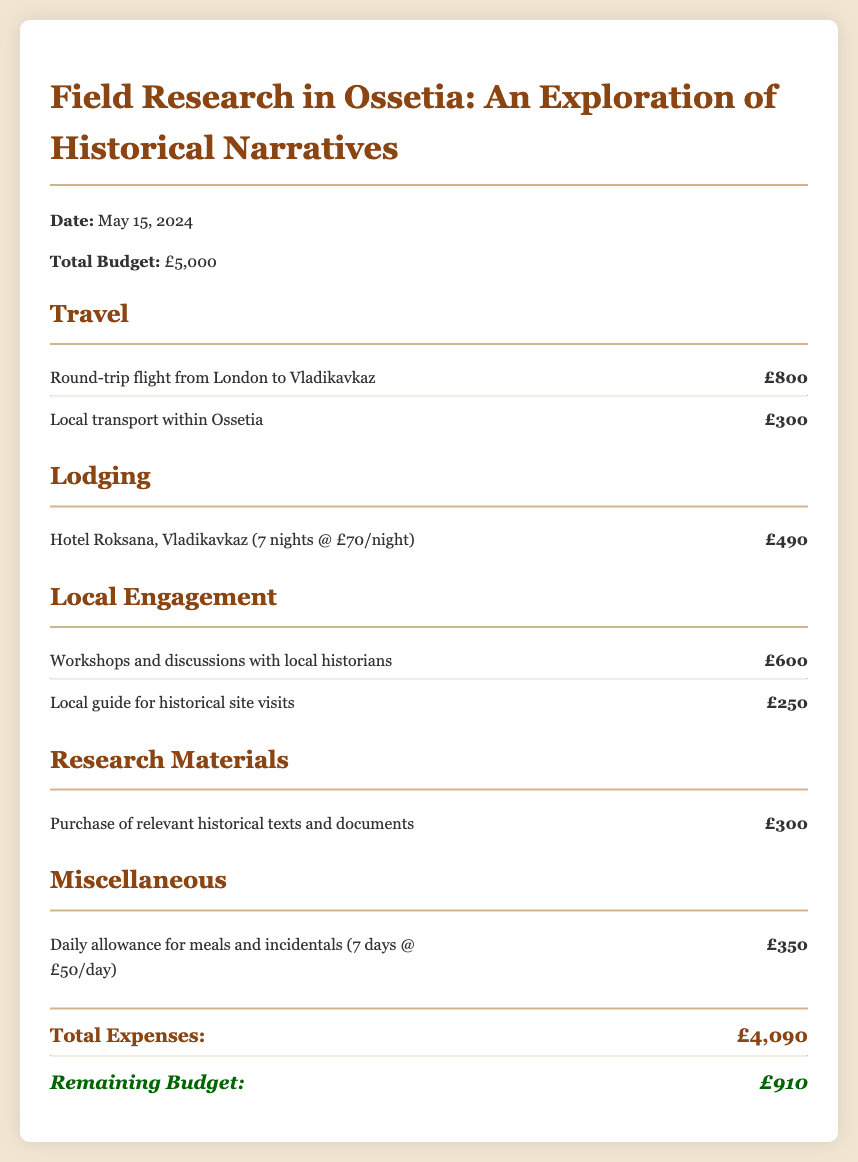what is the date of the research project? The date of the research project is stated at the beginning of the document.
Answer: May 15, 2024 what is the total budget for the research? The total budget is mentioned in the budget overview at the top of the document.
Answer: £5,000 how much is allocated for local transport within Ossetia? The amount for local transport is detailed in the travel section of the budget.
Answer: £300 what is the cost of lodging at Hotel Roksana for 7 nights? The cost of lodging is calculated based on the nightly rate for 7 nights as mentioned in the lodging section.
Answer: £490 how much is budgeted for workshops with local historians? The budget for workshops is outlined in the local engagement section of the document.
Answer: £600 what is the total amount of expenses listed? The total expenses can be calculated by adding up all the costs presented in the document.
Answer: £4,090 how much is the remaining budget after all expenses? The remaining budget is shown in the conclusion of the budget overview.
Answer: £910 how many days does the daily allowance cover? The daily allowance is calculated for the number of days specified in the miscellaneous section.
Answer: 7 days what is the cost of the round-trip flight from London to Vladikavkaz? The cost for the flight is stated in the travel budget section.
Answer: £800 